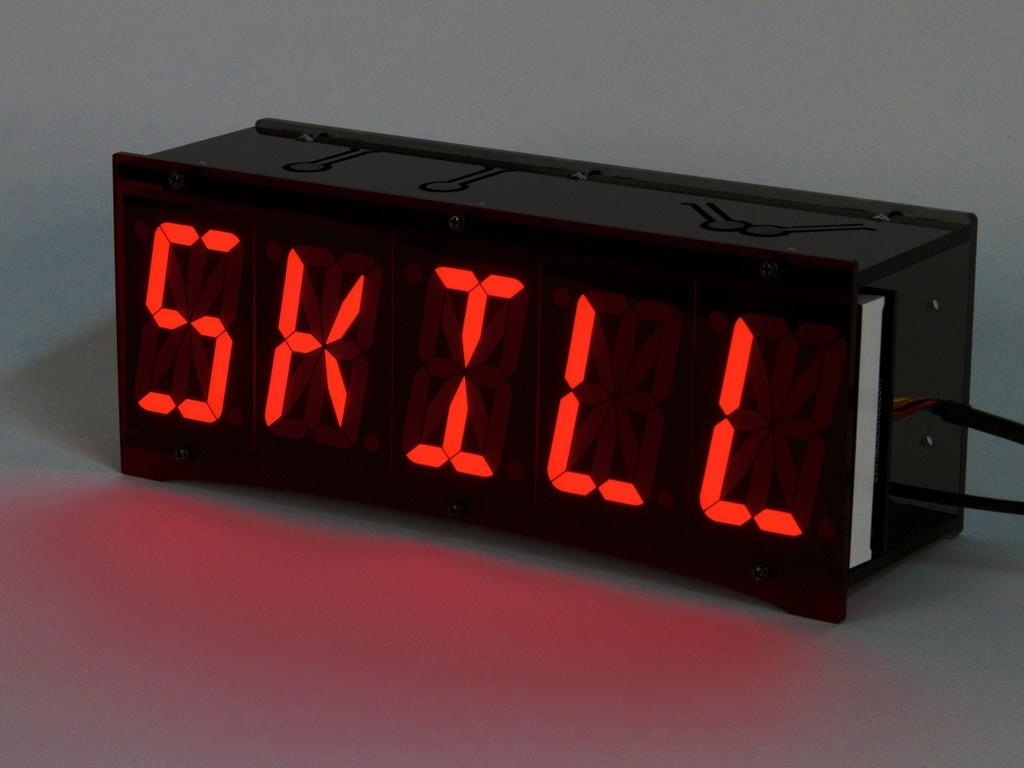Provide a one-sentence caption for the provided image. Digital looking clockish rectangular black plastic piece with the words SKILL written out in red. 